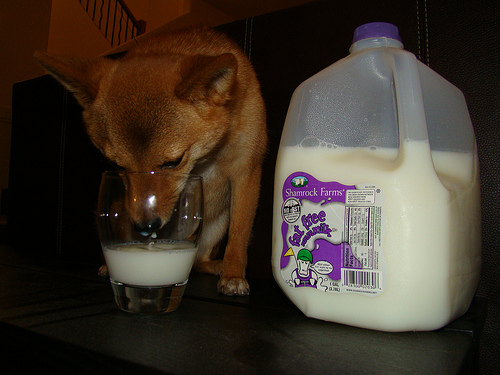<image>
Is the dog next to the milk gallon? Yes. The dog is positioned adjacent to the milk gallon, located nearby in the same general area. 